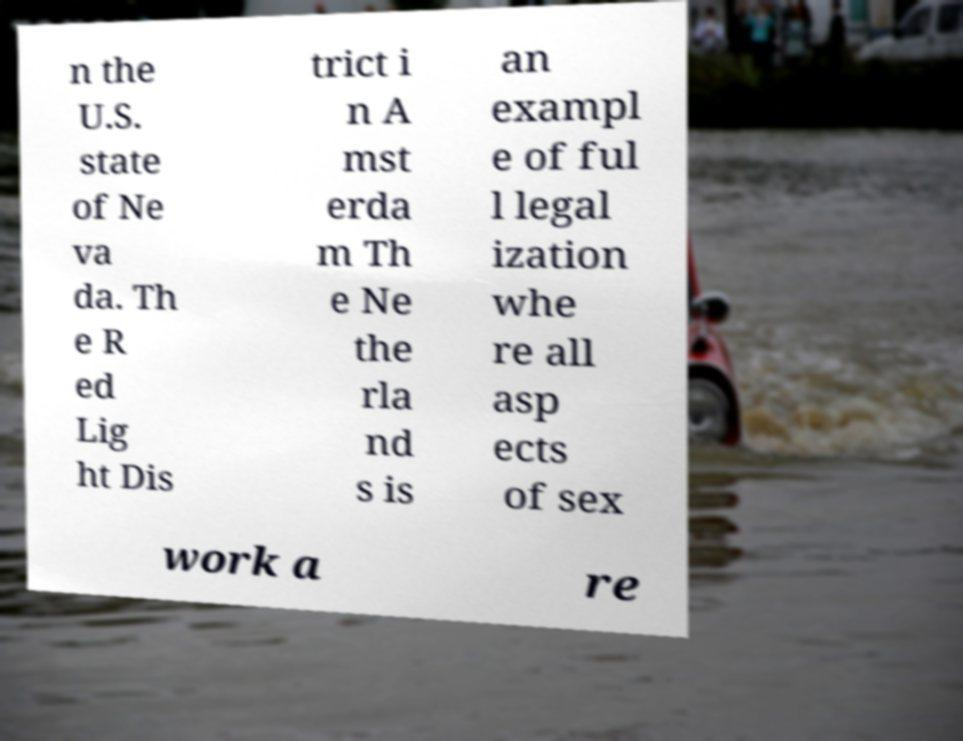Can you accurately transcribe the text from the provided image for me? n the U.S. state of Ne va da. Th e R ed Lig ht Dis trict i n A mst erda m Th e Ne the rla nd s is an exampl e of ful l legal ization whe re all asp ects of sex work a re 